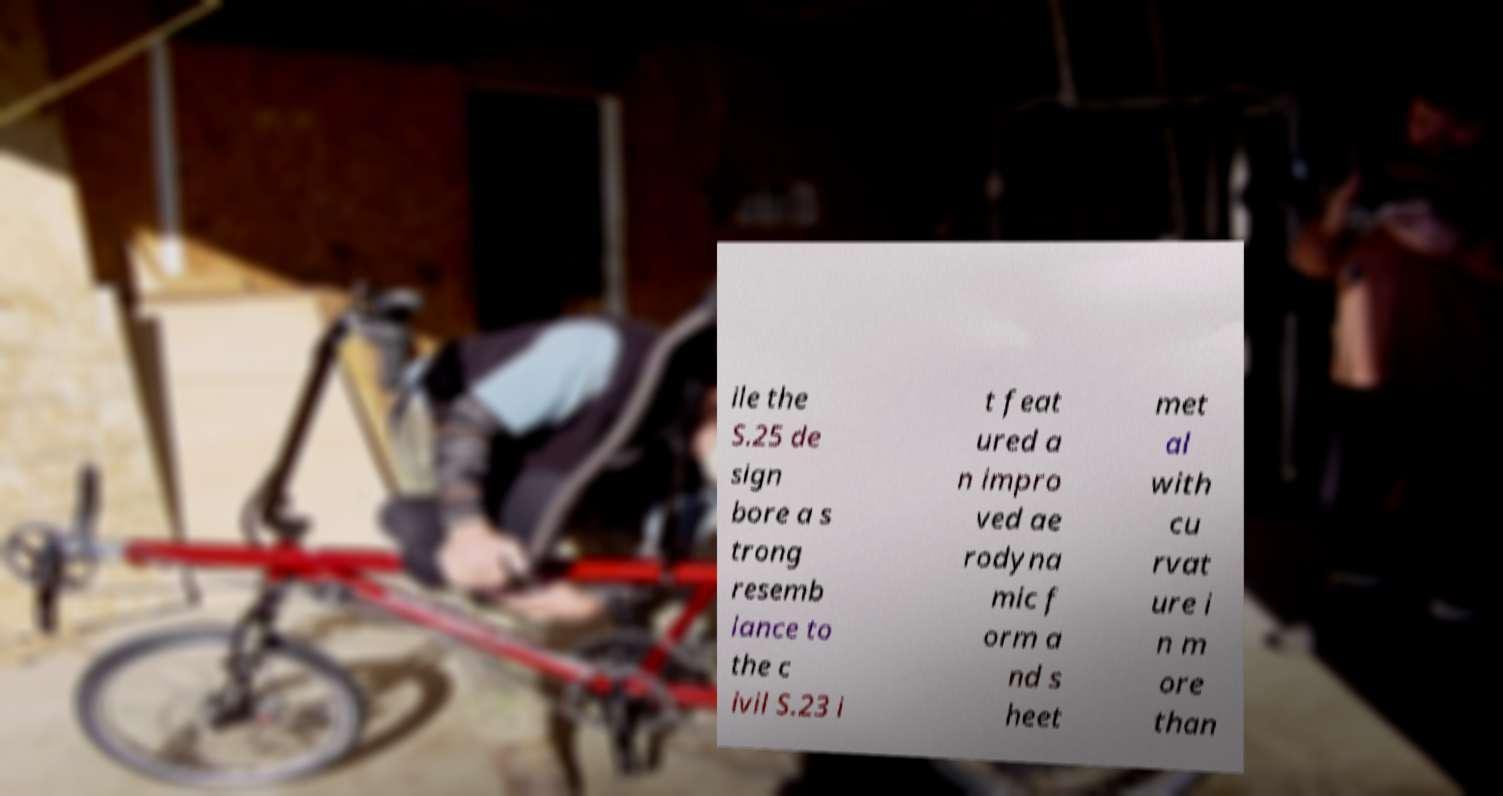What messages or text are displayed in this image? I need them in a readable, typed format. ile the S.25 de sign bore a s trong resemb lance to the c ivil S.23 i t feat ured a n impro ved ae rodyna mic f orm a nd s heet met al with cu rvat ure i n m ore than 